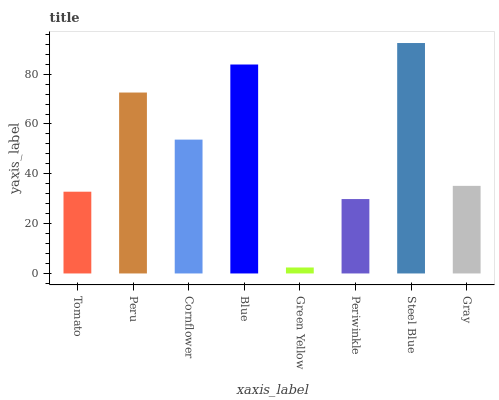Is Green Yellow the minimum?
Answer yes or no. Yes. Is Steel Blue the maximum?
Answer yes or no. Yes. Is Peru the minimum?
Answer yes or no. No. Is Peru the maximum?
Answer yes or no. No. Is Peru greater than Tomato?
Answer yes or no. Yes. Is Tomato less than Peru?
Answer yes or no. Yes. Is Tomato greater than Peru?
Answer yes or no. No. Is Peru less than Tomato?
Answer yes or no. No. Is Cornflower the high median?
Answer yes or no. Yes. Is Gray the low median?
Answer yes or no. Yes. Is Peru the high median?
Answer yes or no. No. Is Steel Blue the low median?
Answer yes or no. No. 